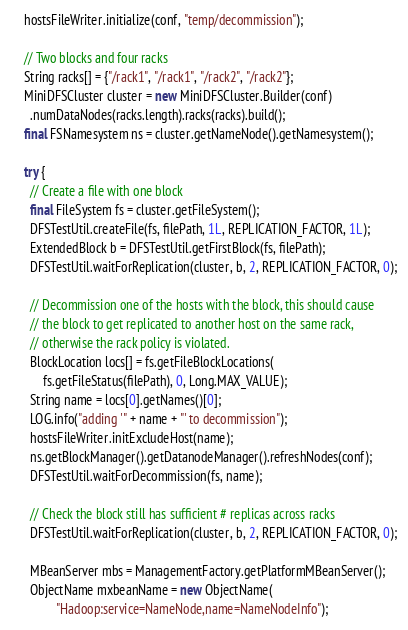Convert code to text. <code><loc_0><loc_0><loc_500><loc_500><_Java_>    hostsFileWriter.initialize(conf, "temp/decommission");

    // Two blocks and four racks
    String racks[] = {"/rack1", "/rack1", "/rack2", "/rack2"};
    MiniDFSCluster cluster = new MiniDFSCluster.Builder(conf)
      .numDataNodes(racks.length).racks(racks).build();
    final FSNamesystem ns = cluster.getNameNode().getNamesystem();

    try {
      // Create a file with one block
      final FileSystem fs = cluster.getFileSystem();
      DFSTestUtil.createFile(fs, filePath, 1L, REPLICATION_FACTOR, 1L);
      ExtendedBlock b = DFSTestUtil.getFirstBlock(fs, filePath);
      DFSTestUtil.waitForReplication(cluster, b, 2, REPLICATION_FACTOR, 0);

      // Decommission one of the hosts with the block, this should cause 
      // the block to get replicated to another host on the same rack,
      // otherwise the rack policy is violated.
      BlockLocation locs[] = fs.getFileBlockLocations(
          fs.getFileStatus(filePath), 0, Long.MAX_VALUE);
      String name = locs[0].getNames()[0];
      LOG.info("adding '" + name + "' to decommission");
      hostsFileWriter.initExcludeHost(name);
      ns.getBlockManager().getDatanodeManager().refreshNodes(conf);
      DFSTestUtil.waitForDecommission(fs, name);

      // Check the block still has sufficient # replicas across racks
      DFSTestUtil.waitForReplication(cluster, b, 2, REPLICATION_FACTOR, 0);

      MBeanServer mbs = ManagementFactory.getPlatformMBeanServer();
      ObjectName mxbeanName = new ObjectName(
              "Hadoop:service=NameNode,name=NameNodeInfo");</code> 